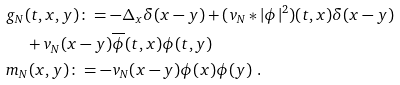Convert formula to latex. <formula><loc_0><loc_0><loc_500><loc_500>& g _ { N } ( t , x , y ) \colon = - \Delta _ { x } \delta ( x - y ) + ( v _ { N } * | \phi | ^ { 2 } ) ( t , x ) \delta ( x - y ) \\ & \quad \ + v _ { N } ( x - y ) \overline { \phi } ( t , x ) \phi ( t , y ) \\ & m _ { N } ( x , y ) \colon = - v _ { N } ( x - y ) \phi ( x ) \phi ( y ) \ .</formula> 